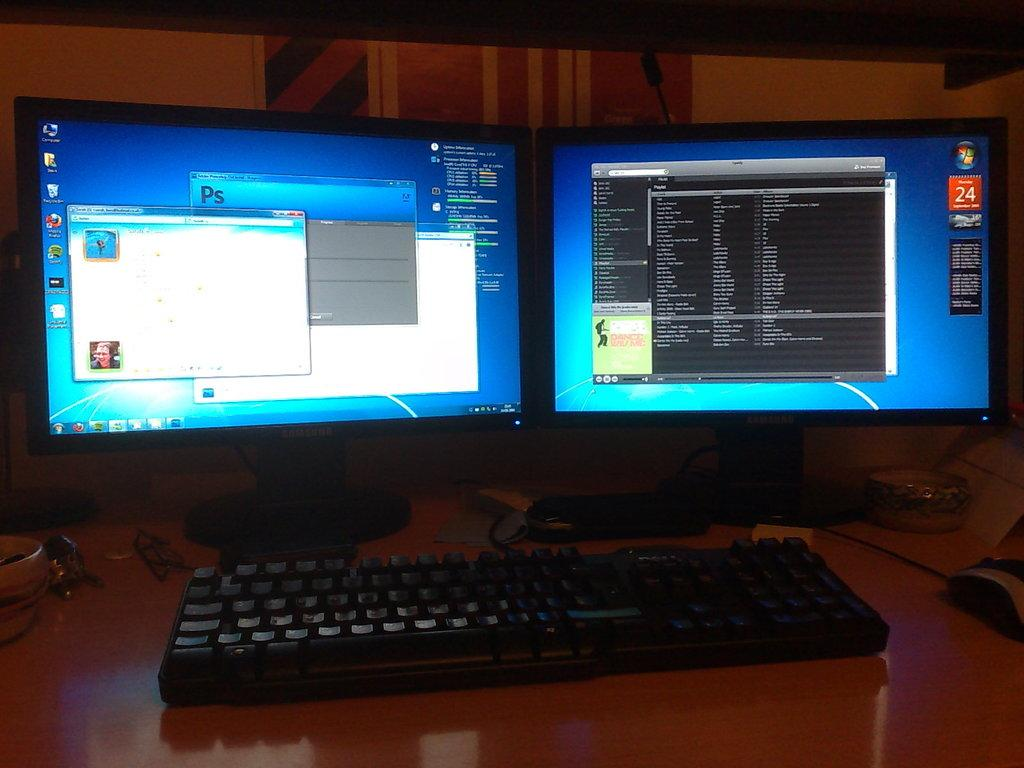<image>
Offer a succinct explanation of the picture presented. Two computer monitors with one saying "PS" on it. 